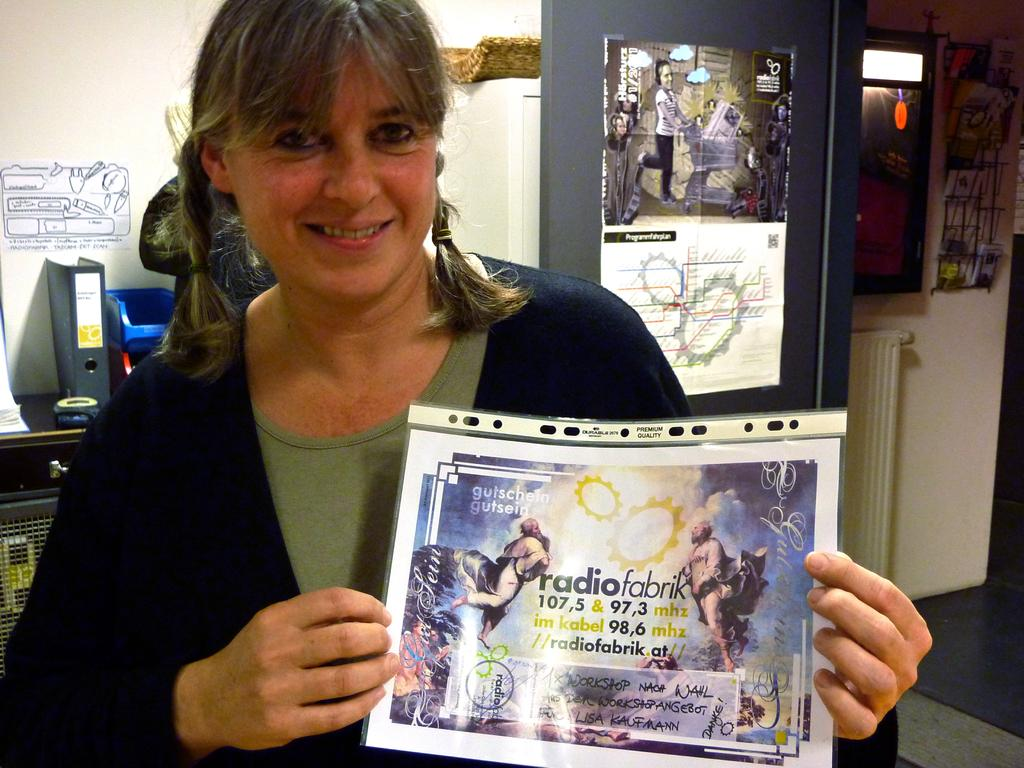<image>
Render a clear and concise summary of the photo. A woman holds a flyer for RadioFabrik in a plastic sleeve. 